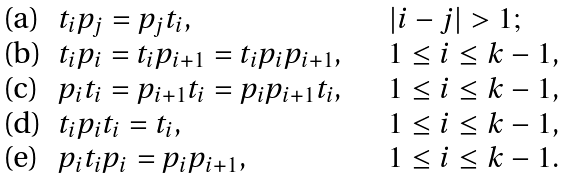Convert formula to latex. <formula><loc_0><loc_0><loc_500><loc_500>\begin{array} { l l l } \text {(a)} & t _ { i } p _ { j } = p _ { j } t _ { i } , & | i - j | > 1 ; \\ \text {(b)} & t _ { i } p _ { i } = t _ { i } p _ { i + 1 } = t _ { i } p _ { i } p _ { i + 1 } , & 1 \leq i \leq k - 1 , \\ \text {(c)} & p _ { i } t _ { i } = p _ { i + 1 } t _ { i } = p _ { i } p _ { i + 1 } t _ { i } , \quad & 1 \leq i \leq k - 1 , \\ \text {(d)} & t _ { i } p _ { i } t _ { i } = t _ { i } , & 1 \leq i \leq k - 1 , \\ \text {(e)} & p _ { i } t _ { i } p _ { i } = p _ { i } p _ { i + 1 } , & 1 \leq i \leq k - 1 . \end{array}</formula> 